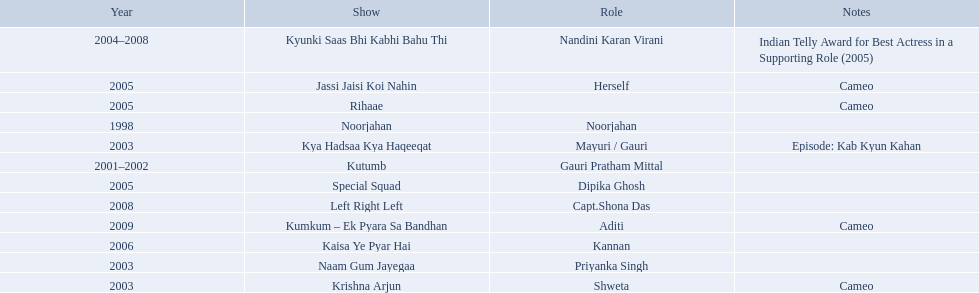In 1998 what was the role of gauri pradhan tejwani? Noorjahan. In 2003 what show did gauri have a cameo in? Krishna Arjun. Gauri was apart of which television show for the longest? Kyunki Saas Bhi Kabhi Bahu Thi. 